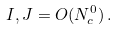<formula> <loc_0><loc_0><loc_500><loc_500>I , J = O ( N _ { c } ^ { 0 } ) \, .</formula> 